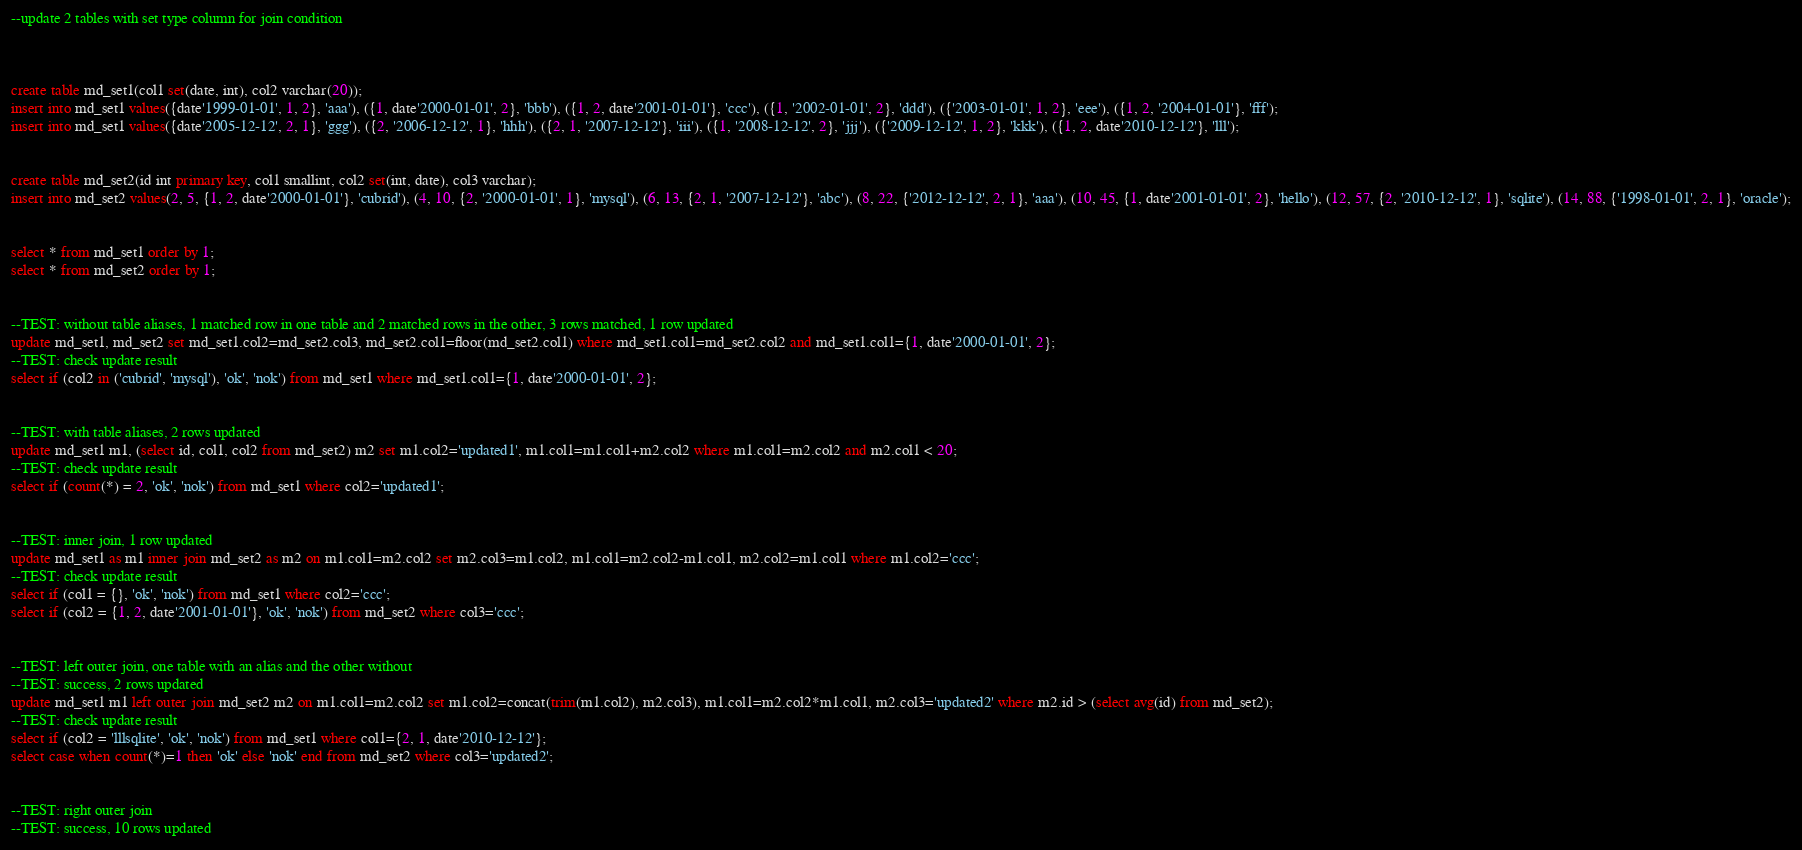<code> <loc_0><loc_0><loc_500><loc_500><_SQL_>--update 2 tables with set type column for join condition



create table md_set1(col1 set(date, int), col2 varchar(20));
insert into md_set1 values({date'1999-01-01', 1, 2}, 'aaa'), ({1, date'2000-01-01', 2}, 'bbb'), ({1, 2, date'2001-01-01'}, 'ccc'), ({1, '2002-01-01', 2}, 'ddd'), ({'2003-01-01', 1, 2}, 'eee'), ({1, 2, '2004-01-01'}, 'fff');
insert into md_set1 values({date'2005-12-12', 2, 1}, 'ggg'), ({2, '2006-12-12', 1}, 'hhh'), ({2, 1, '2007-12-12'}, 'iii'), ({1, '2008-12-12', 2}, 'jjj'), ({'2009-12-12', 1, 2}, 'kkk'), ({1, 2, date'2010-12-12'}, 'lll');


create table md_set2(id int primary key, col1 smallint, col2 set(int, date), col3 varchar);
insert into md_set2 values(2, 5, {1, 2, date'2000-01-01'}, 'cubrid'), (4, 10, {2, '2000-01-01', 1}, 'mysql'), (6, 13, {2, 1, '2007-12-12'}, 'abc'), (8, 22, {'2012-12-12', 2, 1}, 'aaa'), (10, 45, {1, date'2001-01-01', 2}, 'hello'), (12, 57, {2, '2010-12-12', 1}, 'sqlite'), (14, 88, {'1998-01-01', 2, 1}, 'oracle');


select * from md_set1 order by 1;
select * from md_set2 order by 1;


--TEST: without table aliases, 1 matched row in one table and 2 matched rows in the other, 3 rows matched, 1 row updated 
update md_set1, md_set2 set md_set1.col2=md_set2.col3, md_set2.col1=floor(md_set2.col1) where md_set1.col1=md_set2.col2 and md_set1.col1={1, date'2000-01-01', 2};
--TEST: check update result
select if (col2 in ('cubrid', 'mysql'), 'ok', 'nok') from md_set1 where md_set1.col1={1, date'2000-01-01', 2};


--TEST: with table aliases, 2 rows updated
update md_set1 m1, (select id, col1, col2 from md_set2) m2 set m1.col2='updated1', m1.col1=m1.col1+m2.col2 where m1.col1=m2.col2 and m2.col1 < 20;
--TEST: check update result
select if (count(*) = 2, 'ok', 'nok') from md_set1 where col2='updated1';


--TEST: inner join, 1 row updated
update md_set1 as m1 inner join md_set2 as m2 on m1.col1=m2.col2 set m2.col3=m1.col2, m1.col1=m2.col2-m1.col1, m2.col2=m1.col1 where m1.col2='ccc';
--TEST: check update result
select if (col1 = {}, 'ok', 'nok') from md_set1 where col2='ccc';
select if (col2 = {1, 2, date'2001-01-01'}, 'ok', 'nok') from md_set2 where col3='ccc';


--TEST: left outer join, one table with an alias and the other without
--TEST: success, 2 rows updated
update md_set1 m1 left outer join md_set2 m2 on m1.col1=m2.col2 set m1.col2=concat(trim(m1.col2), m2.col3), m1.col1=m2.col2*m1.col1, m2.col3='updated2' where m2.id > (select avg(id) from md_set2);
--TEST: check update result
select if (col2 = 'lllsqlite', 'ok', 'nok') from md_set1 where col1={2, 1, date'2010-12-12'};
select case when count(*)=1 then 'ok' else 'nok' end from md_set2 where col3='updated2';


--TEST: right outer join
--TEST: success, 10 rows updated</code> 